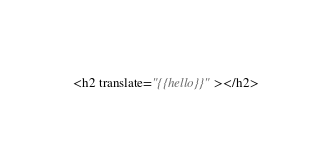Convert code to text. <code><loc_0><loc_0><loc_500><loc_500><_HTML_><h2 translate="{{hello}}"></h2>
</code> 